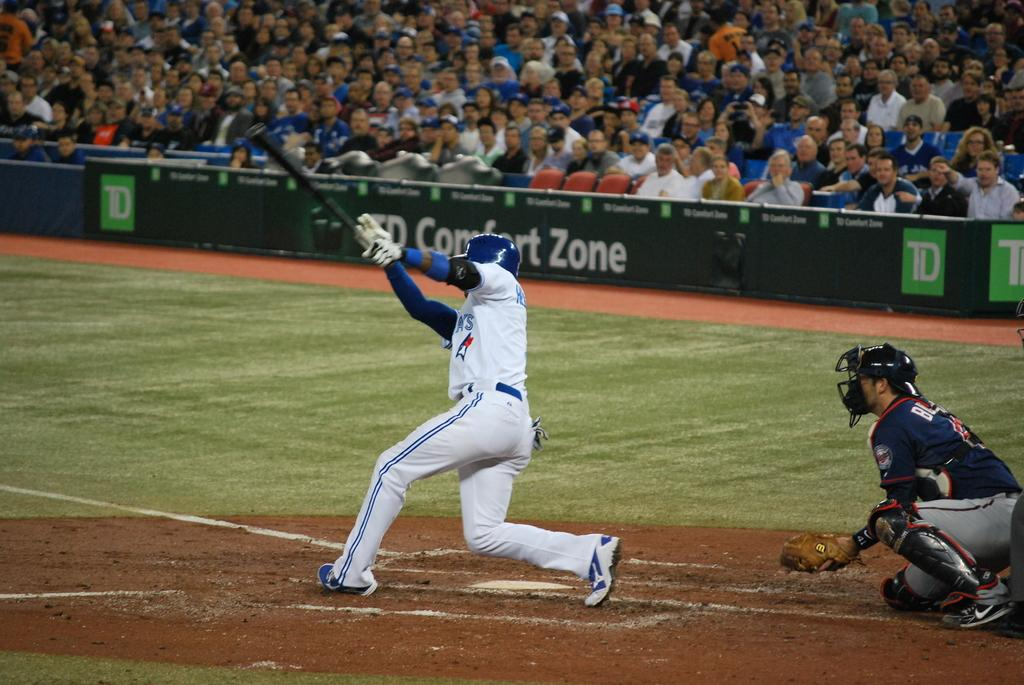<image>
Describe the image concisely. a player hitting a ball at a baseball game with comfort zone near him 